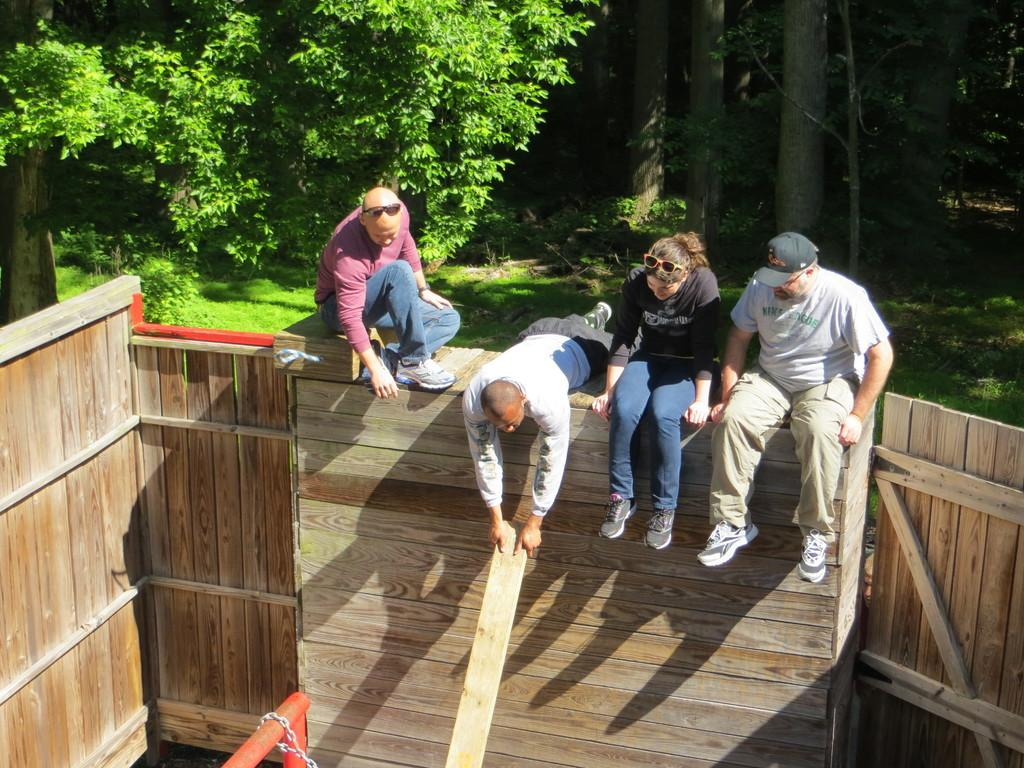How many people are sitting on the wooden surface in the image? There are three persons sitting on a wooden surface in the image. What is the position of the fourth person in the image? The fourth person is lying on the wooden surface. What can be seen in the background of the image? There are trees in the background of the image. What type of decision can be seen being made by the bushes in the image? There are no bushes present in the image, and therefore no decisions can be made by them. 